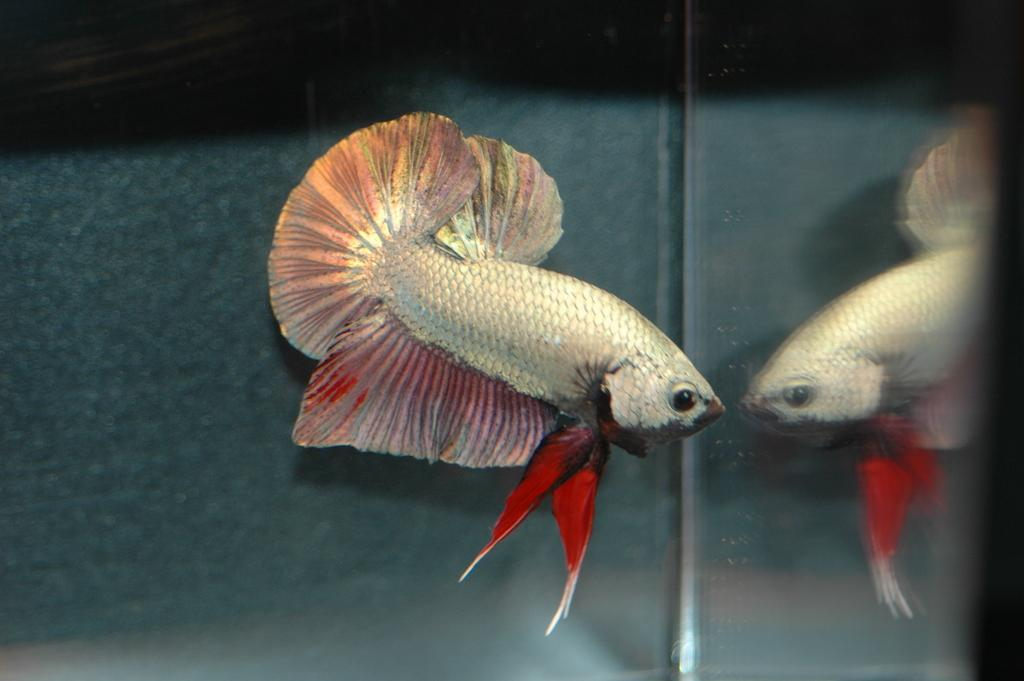What is the main subject of the image? There is a fish in the image. Can you describe any additional features of the fish? The fish has a reflection in the image. What can be seen in the background of the image? The background appears to be a wall. What type of lunchroom is visible in the image? There is no lunchroom present in the image; it features a fish with a reflection against a wall. What is the market value of the fish in the image? There is no information about the market value of the fish in the image, as it is a still image and not a real-life scenario. 